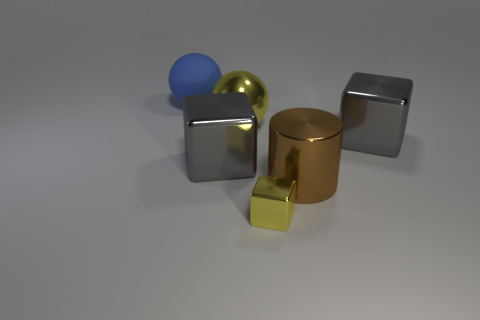What is the size of the other thing that is the same shape as the big blue object?
Keep it short and to the point. Large. Are there any big yellow objects right of the large brown object?
Provide a short and direct response. No. What is the material of the brown thing?
Your answer should be very brief. Metal. Is the color of the cube left of the tiny shiny object the same as the big metallic ball?
Ensure brevity in your answer.  No. Is there anything else that is the same shape as the big yellow metal object?
Ensure brevity in your answer.  Yes. What is the color of the metal thing that is the same shape as the blue rubber object?
Offer a very short reply. Yellow. There is a large cube right of the small object; what is its material?
Make the answer very short. Metal. What is the color of the rubber object?
Offer a very short reply. Blue. There is a gray metallic block that is to the right of the brown shiny thing; does it have the same size as the blue ball?
Offer a terse response. Yes. What material is the sphere in front of the large ball that is behind the big ball in front of the big rubber ball made of?
Your answer should be very brief. Metal. 